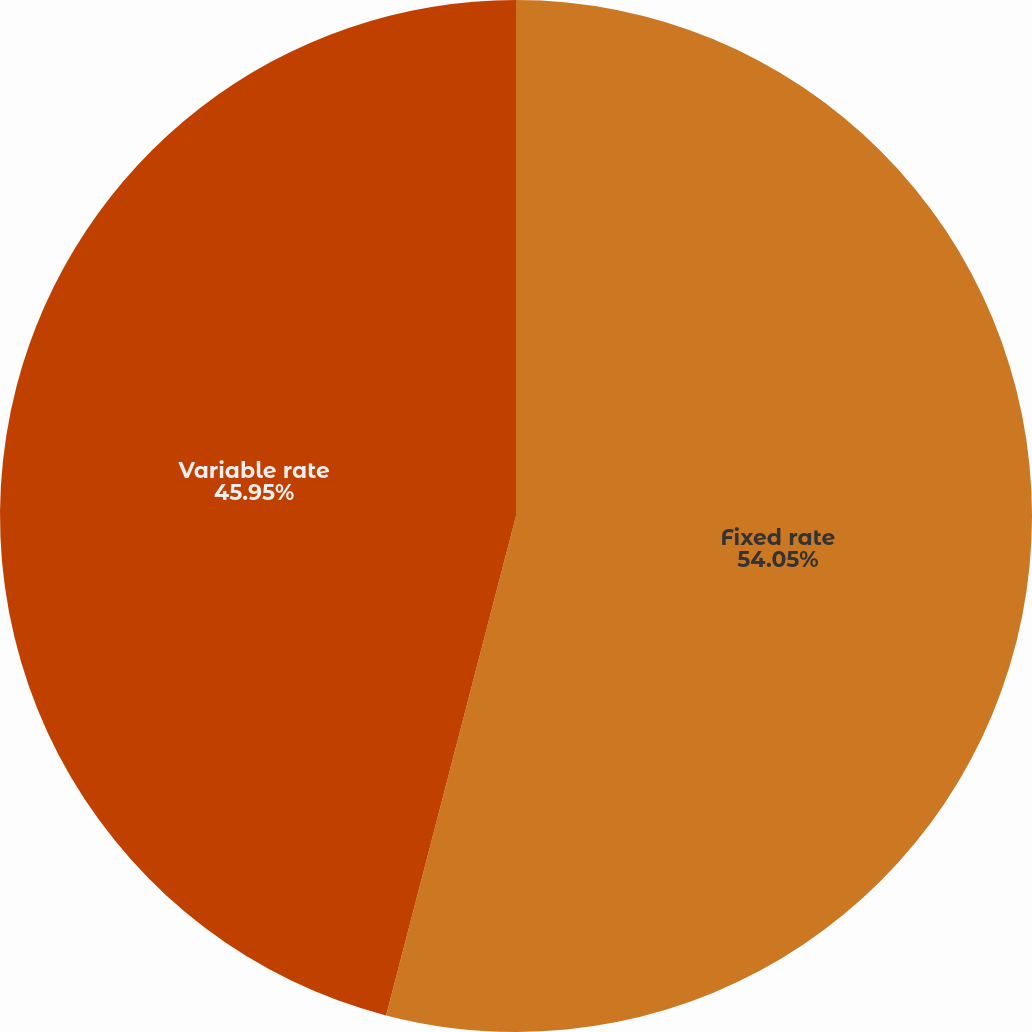Convert chart. <chart><loc_0><loc_0><loc_500><loc_500><pie_chart><fcel>Fixed rate<fcel>Variable rate<nl><fcel>54.05%<fcel>45.95%<nl></chart> 